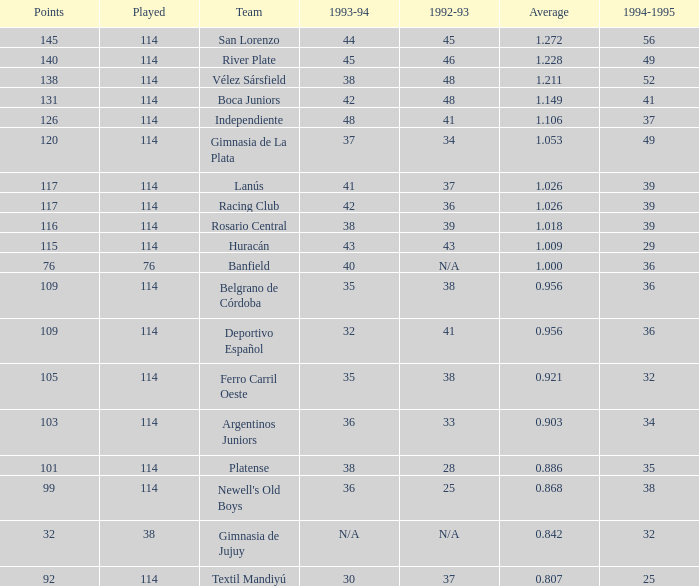Name the most played 114.0. 